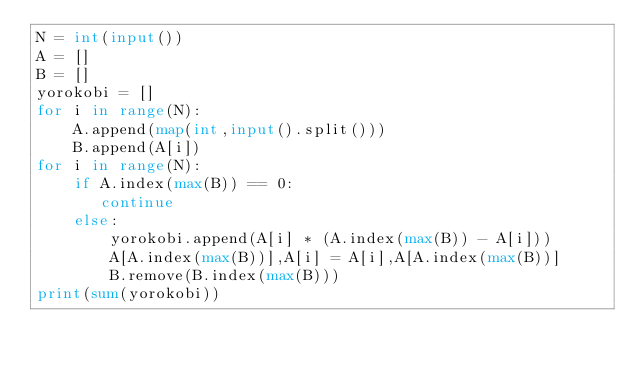Convert code to text. <code><loc_0><loc_0><loc_500><loc_500><_Python_>N = int(input())
A = []
B = []
yorokobi = []
for i in range(N):
    A.append(map(int,input().split()))
    B.append(A[i])
for i in range(N):
    if A.index(max(B)) == 0:
       continue
    else:
        yorokobi.append(A[i] * (A.index(max(B)) - A[i]))
        A[A.index(max(B))],A[i] = A[i],A[A.index(max(B))]
        B.remove(B.index(max(B)))
print(sum(yorokobi))
</code> 